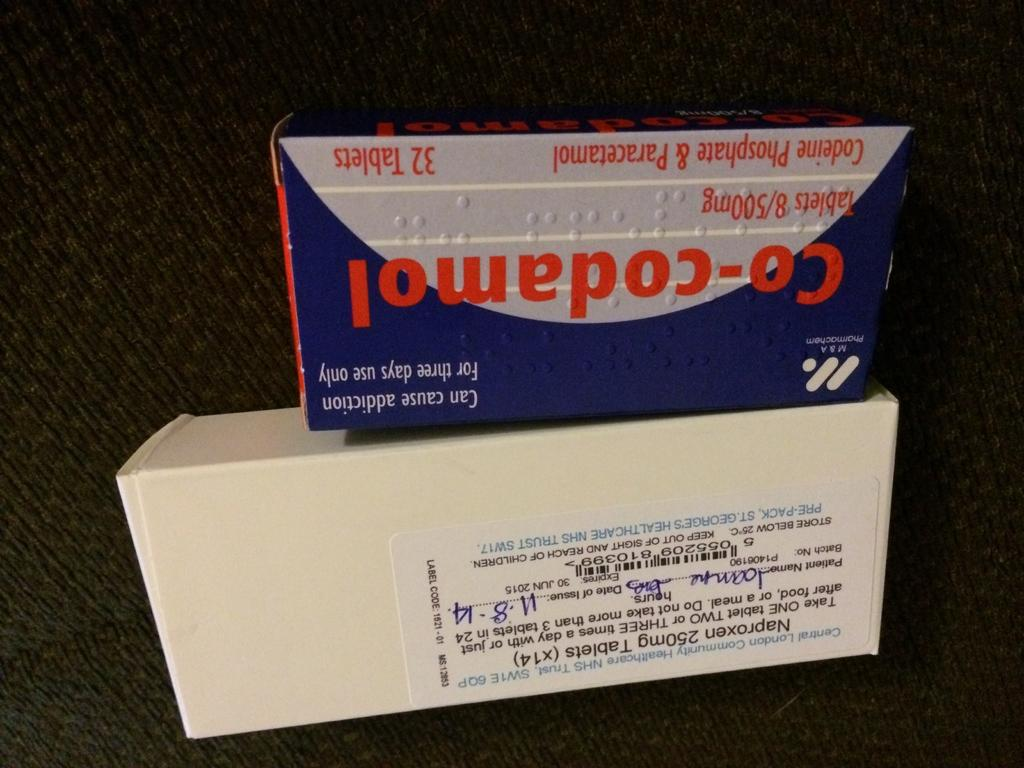<image>
Summarize the visual content of the image. A box of Co-Codamol sits upside down on top of a white box. 